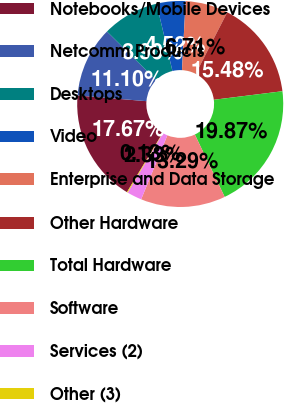<chart> <loc_0><loc_0><loc_500><loc_500><pie_chart><fcel>Notebooks/Mobile Devices<fcel>Netcomm Products<fcel>Desktops<fcel>Video<fcel>Enterprise and Data Storage<fcel>Other Hardware<fcel>Total Hardware<fcel>Software<fcel>Services (2)<fcel>Other (3)<nl><fcel>17.67%<fcel>11.1%<fcel>8.9%<fcel>4.52%<fcel>6.71%<fcel>15.48%<fcel>19.87%<fcel>13.29%<fcel>2.33%<fcel>0.13%<nl></chart> 